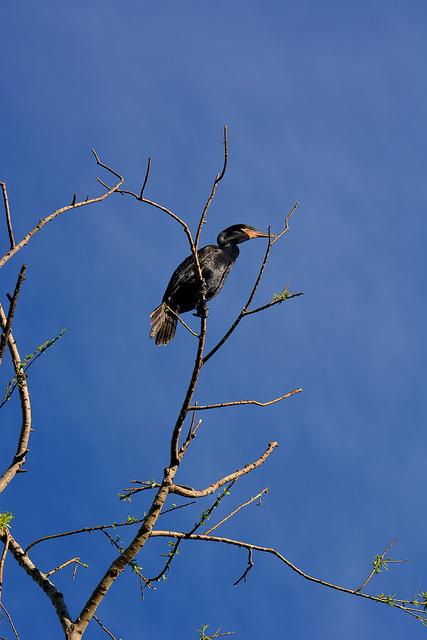Are the birds sitting or standing?
Keep it brief. Sitting. How can you tell it is early spring?
Write a very short answer. Bare branches of tree. How did the animal get to where it is sitting?
Quick response, please. Flew. How long has this species of bird been on the earth?
Short answer required. Forever. 